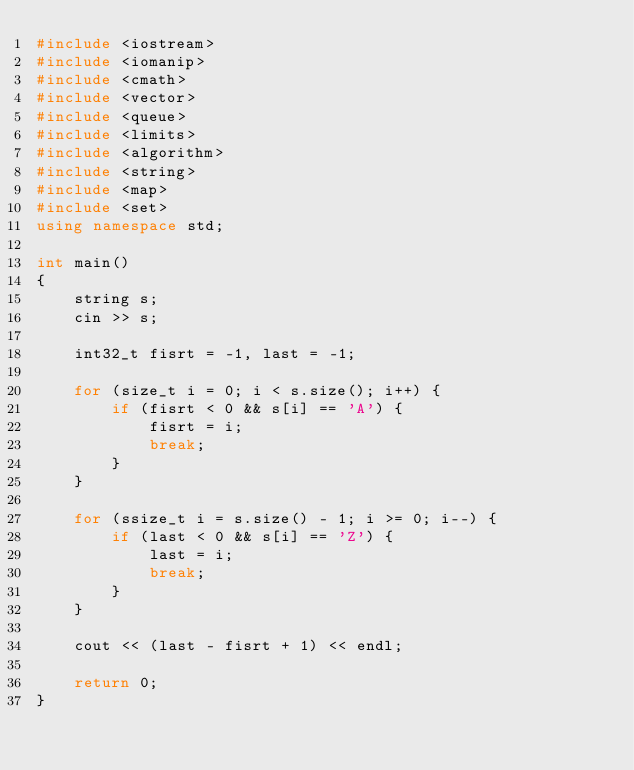<code> <loc_0><loc_0><loc_500><loc_500><_C++_>#include <iostream>
#include <iomanip>
#include <cmath>
#include <vector>
#include <queue>
#include <limits>
#include <algorithm>
#include <string>
#include <map>
#include <set>
using namespace std;

int main()
{
	string s;
	cin >> s;

	int32_t fisrt = -1, last = -1;

	for (size_t i = 0; i < s.size(); i++) {
		if (fisrt < 0 && s[i] == 'A') {
			fisrt = i;
			break;
		}
	}

	for (ssize_t i = s.size() - 1; i >= 0; i--) {
		if (last < 0 && s[i] == 'Z') {
			last = i;
			break;
		}
	}

	cout << (last - fisrt + 1) << endl;

	return 0;
}</code> 